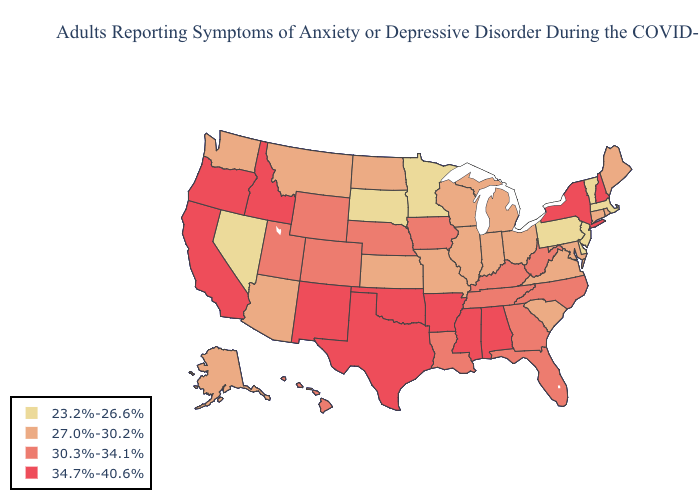Among the states that border Kansas , which have the lowest value?
Give a very brief answer. Missouri. Does the first symbol in the legend represent the smallest category?
Short answer required. Yes. Does Massachusetts have the highest value in the USA?
Write a very short answer. No. Does Nevada have the same value as Rhode Island?
Concise answer only. No. What is the lowest value in the MidWest?
Be succinct. 23.2%-26.6%. What is the value of Arizona?
Give a very brief answer. 27.0%-30.2%. What is the lowest value in the USA?
Short answer required. 23.2%-26.6%. What is the value of Nevada?
Concise answer only. 23.2%-26.6%. Does Wyoming have the same value as Colorado?
Give a very brief answer. Yes. Among the states that border Idaho , which have the lowest value?
Answer briefly. Nevada. What is the lowest value in the West?
Quick response, please. 23.2%-26.6%. Does the map have missing data?
Concise answer only. No. What is the value of Pennsylvania?
Write a very short answer. 23.2%-26.6%. Which states have the highest value in the USA?
Keep it brief. Alabama, Arkansas, California, Idaho, Mississippi, New Hampshire, New Mexico, New York, Oklahoma, Oregon, Texas. What is the value of Delaware?
Be succinct. 23.2%-26.6%. 